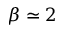<formula> <loc_0><loc_0><loc_500><loc_500>\beta \simeq 2</formula> 